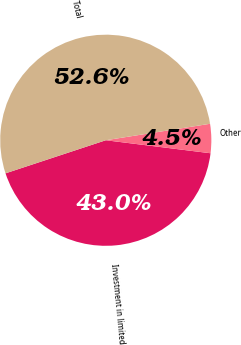<chart> <loc_0><loc_0><loc_500><loc_500><pie_chart><fcel>Investment in limited<fcel>Other<fcel>Total<nl><fcel>42.96%<fcel>4.46%<fcel>52.58%<nl></chart> 